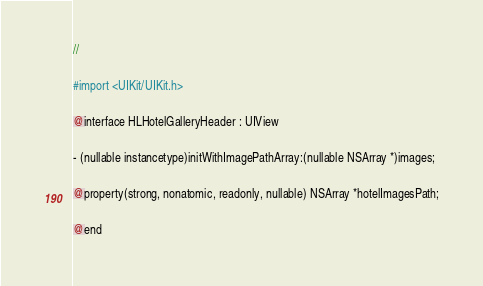<code> <loc_0><loc_0><loc_500><loc_500><_C_>//

#import <UIKit/UIKit.h>

@interface HLHotelGalleryHeader : UIView

- (nullable instancetype)initWithImagePathArray:(nullable NSArray *)images;

@property(strong, nonatomic, readonly, nullable) NSArray *hotelImagesPath;

@end
</code> 